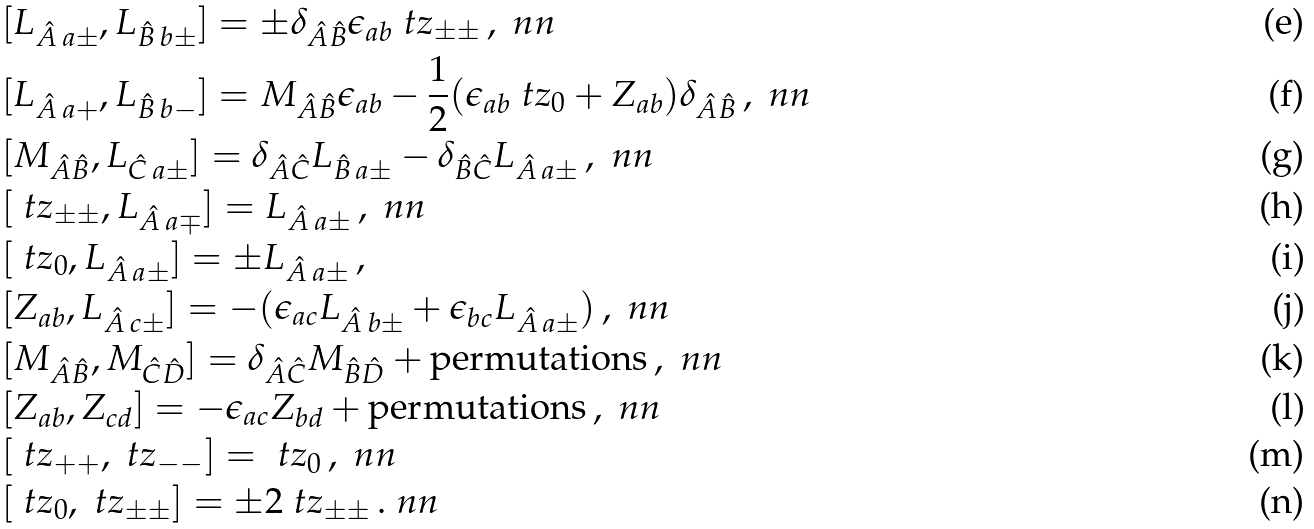Convert formula to latex. <formula><loc_0><loc_0><loc_500><loc_500>& [ L _ { { \hat { A } } \, a \pm } , L _ { { \hat { B } } \, b \pm } ] = \pm \delta _ { { \hat { A } } { \hat { B } } } \epsilon _ { a b } \ t z _ { \pm \pm } \, , \ n n \\ & [ L _ { { \hat { A } } \, a + } , L _ { { \hat { B } } \, b - } ] = M _ { { \hat { A } } { \hat { B } } } \epsilon _ { a b } - \frac { 1 } { 2 } ( \epsilon _ { a b } \ t z _ { 0 } + Z _ { a b } ) \delta _ { { \hat { A } } { \hat { B } } } \, , \ n n \\ & [ M _ { { \hat { A } } { \hat { B } } } , L _ { { \hat { C } } \, a \pm } ] = \delta _ { { \hat { A } } { \hat { C } } } L _ { { \hat { B } } \, a \pm } - \delta _ { { \hat { B } } { \hat { C } } } L _ { { \hat { A } } \, a \pm } \, , \ n n \\ & [ \ t z _ { \pm \pm } , L _ { { \hat { A } } \, a \mp } ] = L _ { { \hat { A } } \, a \pm } \, , \ n n \\ & [ \ t z _ { 0 } , L _ { { \hat { A } } \, a \pm } ] = \pm L _ { { \hat { A } } \, a \pm } \, , \\ & [ Z _ { a b } , L _ { { \hat { A } } \, c \pm } ] = - ( \epsilon _ { a c } L _ { { \hat { A } } \, b \pm } + \epsilon _ { b c } L _ { { \hat { A } } \, a \pm } ) \, , \ n n \\ & [ M _ { { \hat { A } } { \hat { B } } } , M _ { { \hat { C } } \hat { D } } ] = \delta _ { { \hat { A } } { \hat { C } } } M _ { { \hat { B } } \hat { D } } + \text {permutations} \, , \ n n \\ & [ Z _ { a b } , Z _ { c d } ] = - \epsilon _ { a c } Z _ { b d } + \text {permutations} \, , \ n n \\ & [ \ t z _ { + + } , \ t z _ { - - } ] = \ t z _ { 0 } \, , \ n n \\ & [ \ t z _ { 0 } , \ t z _ { \pm \pm } ] = \pm 2 \ t z _ { \pm \pm } \, . \ n n</formula> 